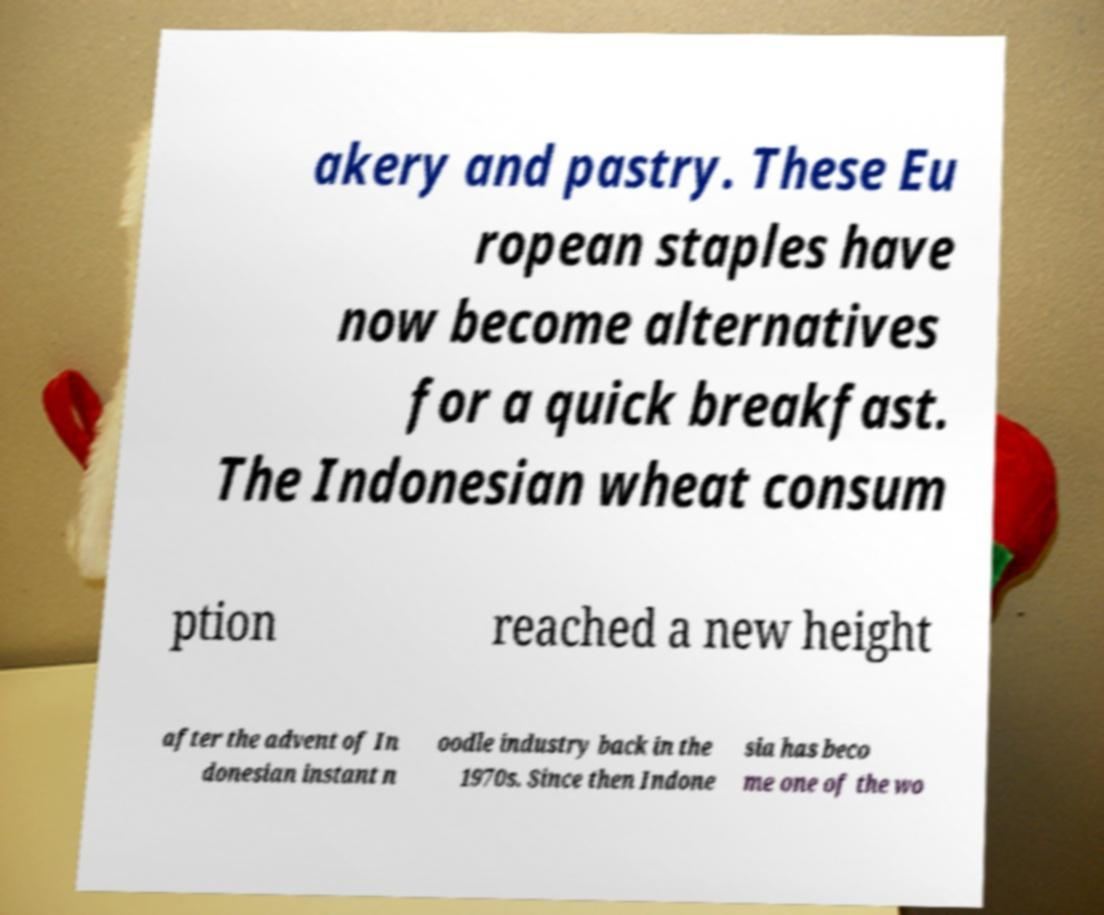I need the written content from this picture converted into text. Can you do that? akery and pastry. These Eu ropean staples have now become alternatives for a quick breakfast. The Indonesian wheat consum ption reached a new height after the advent of In donesian instant n oodle industry back in the 1970s. Since then Indone sia has beco me one of the wo 